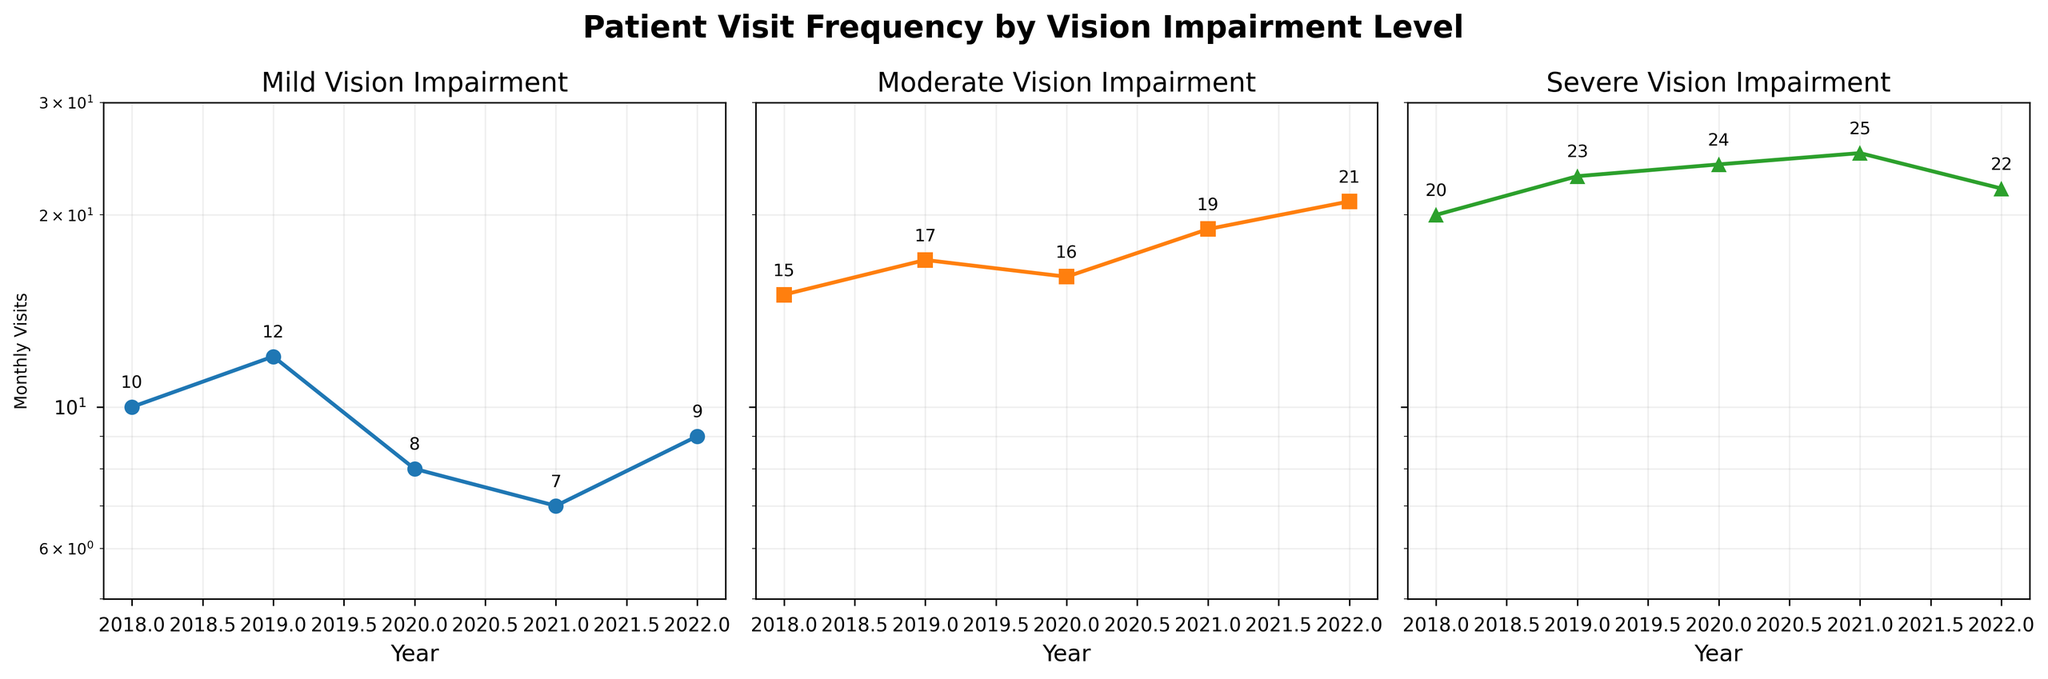Which year had the highest number of monthly visits for patients with severe vision impairment? Look at the subplot titled "Severe Vision Impairment" and find the highest data point. The highest number of monthly visits is 25, recorded in the year 2021.
Answer: 2021 How many different levels of vision impairment are shown in the figure? Count the number of distinct subplots, each representing a different level of vision impairment. There are three subplots: Mild, Moderate, and Severe.
Answer: Three What is the trend of monthly visits for patients with moderate vision impairment from 2018 to 2022? Examine the line in the subplot titled "Moderate Vision Impairment." The trend shows an increase in monthly visits from 15 in 2018 to 21 in 2022.
Answer: Increasing Compare the number of monthly visits in 2020 for patients with mild and moderate vision impairment. In the subplots for Mild and Moderate Vision Impairment, observe the data points for 2020. Mild has 8 visits, while Moderate has 16 visits.
Answer: Moderate had more Which vision impairment level shows the most significant increase in monthly visits over the years? Examine the slopes of the lines in each subplot. The most significant increase in monthly visits is seen in the Moderate Vision Impairment subplot, where the number increases from 15 to 21.
Answer: Moderate What is the average number of monthly visits for patients with mild vision impairment from 2018 to 2022? Sum the monthly visits for Mild Vision Impairment (10, 12, 8, 7, 9) and divide by the number of years (5). (10 + 12 + 8 + 7 + 9) / 5 = 46 / 5 = 9.2
Answer: 9.2 How does the number of monthly visits in 2021 compare between patients with severe and mild vision impairment? In the subplots for Severe and Mild Vision Impairment, observe the data points for 2021. Severe has 25 visits, and Mild has 7 visits. Severe has significantly more visits than Mild.
Answer: Severe had more In which years did patients with moderate vision impairment have the same number of monthly visits? Look at the subplot for Moderate Vision Impairment and identify any years with the same data points. Both 2020 and 2018 recorded 16 monthly visits.
Answer: 2020 and 2018 